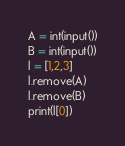Convert code to text. <code><loc_0><loc_0><loc_500><loc_500><_Python_>A = int(input())
B = int(input())
l = [1,2,3]
l.remove(A)
l.remove(B)
print(l[0])</code> 